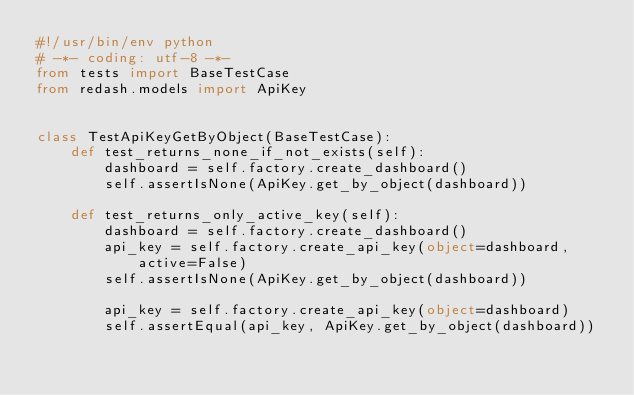Convert code to text. <code><loc_0><loc_0><loc_500><loc_500><_Python_>#!/usr/bin/env python
# -*- coding: utf-8 -*-
from tests import BaseTestCase
from redash.models import ApiKey


class TestApiKeyGetByObject(BaseTestCase):
    def test_returns_none_if_not_exists(self):
        dashboard = self.factory.create_dashboard()
        self.assertIsNone(ApiKey.get_by_object(dashboard))

    def test_returns_only_active_key(self):
        dashboard = self.factory.create_dashboard()
        api_key = self.factory.create_api_key(object=dashboard, active=False)
        self.assertIsNone(ApiKey.get_by_object(dashboard))

        api_key = self.factory.create_api_key(object=dashboard)
        self.assertEqual(api_key, ApiKey.get_by_object(dashboard))

</code> 